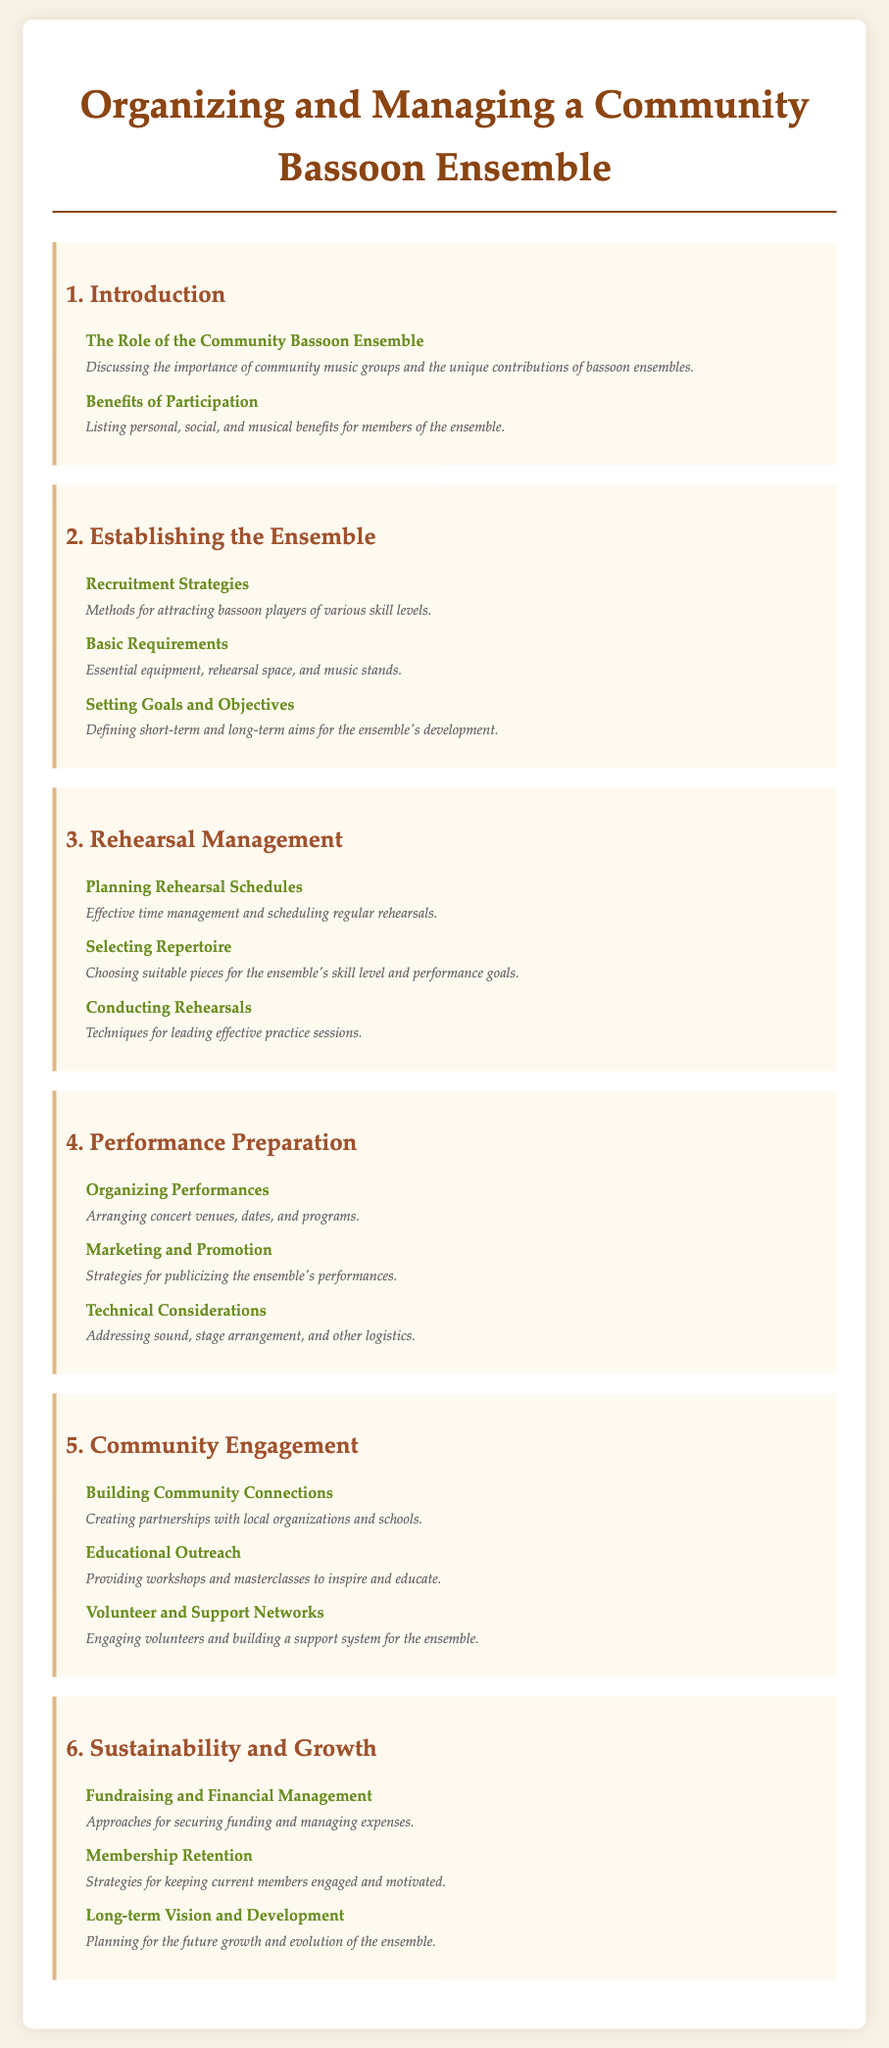What is the title of the document? The title of the document is stated at the top of the rendered content.
Answer: Organizing and Managing a Community Bassoon Ensemble How many sections are in the document? The document lists six main sections, which are enumerated.
Answer: 6 What is one benefit of participation mentioned? The description lists personal, social, and musical benefits for members.
Answer: Benefits of Participation What does the section on rehearsal management include? It specifically covers topics related to planning and conducting rehearsals for the ensemble.
Answer: Rehearsal Management What is a technical consideration addressed in the document? The document outlines sound, stage arrangement, and other logistics as part of technical considerations.
Answer: Technical Considerations Which section deals with building community connections? The document includes a section dedicated to creating partnerships with local organizations and schools.
Answer: Community Engagement What are the recruitment strategies focused on? This topic highlights methods for attracting bassoon players of various skill levels.
Answer: Recruitment Strategies What is mentioned as a key aspect of sustainability? The document emphasizes securing funding and managing expenses for long-term growth.
Answer: Fundraising and Financial Management 